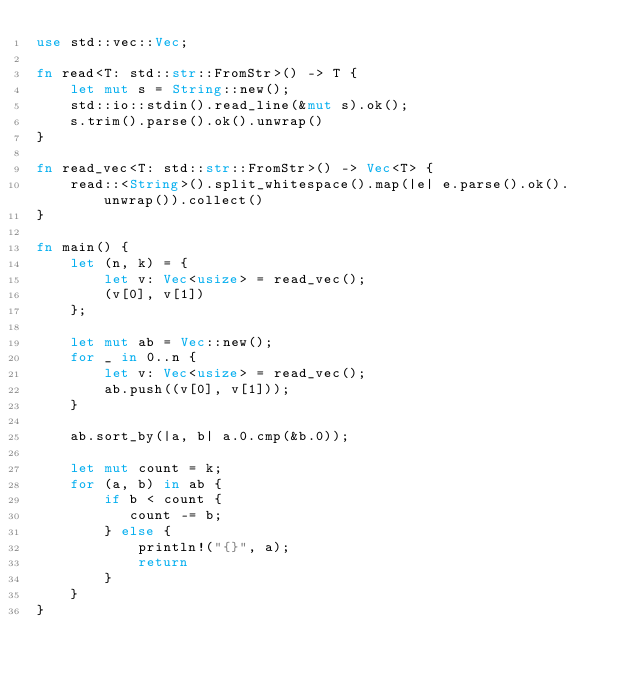<code> <loc_0><loc_0><loc_500><loc_500><_Rust_>use std::vec::Vec;

fn read<T: std::str::FromStr>() -> T {
    let mut s = String::new();
    std::io::stdin().read_line(&mut s).ok();
    s.trim().parse().ok().unwrap()
}

fn read_vec<T: std::str::FromStr>() -> Vec<T> {
    read::<String>().split_whitespace().map(|e| e.parse().ok().unwrap()).collect()
}

fn main() {
    let (n, k) = {
        let v: Vec<usize> = read_vec();
        (v[0], v[1])
    };

    let mut ab = Vec::new();
    for _ in 0..n {
        let v: Vec<usize> = read_vec();
        ab.push((v[0], v[1]));
    }

    ab.sort_by(|a, b| a.0.cmp(&b.0));

    let mut count = k;
    for (a, b) in ab {
        if b < count {
           count -= b;
        } else {
            println!("{}", a);
            return
        }
    }
}
</code> 